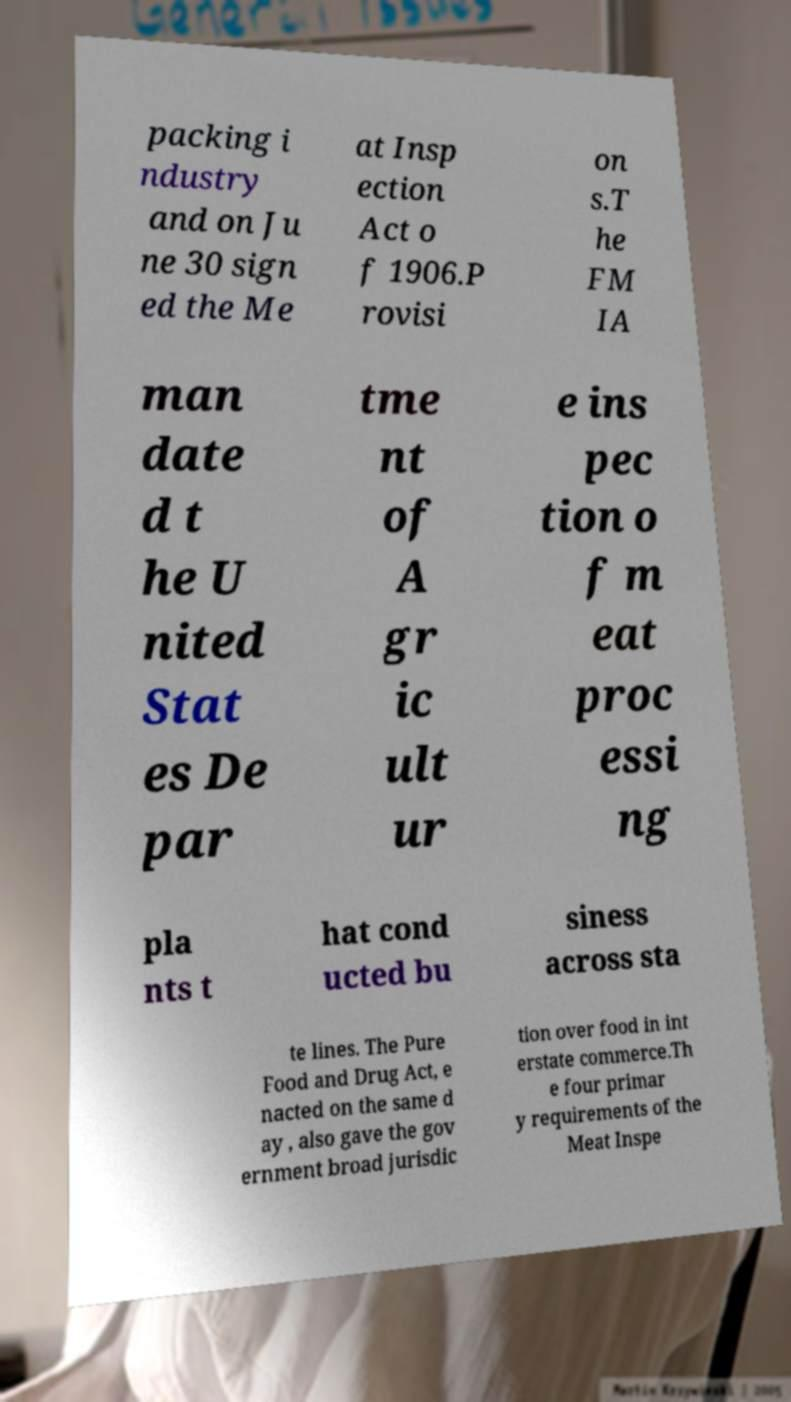Please read and relay the text visible in this image. What does it say? packing i ndustry and on Ju ne 30 sign ed the Me at Insp ection Act o f 1906.P rovisi on s.T he FM IA man date d t he U nited Stat es De par tme nt of A gr ic ult ur e ins pec tion o f m eat proc essi ng pla nts t hat cond ucted bu siness across sta te lines. The Pure Food and Drug Act, e nacted on the same d ay , also gave the gov ernment broad jurisdic tion over food in int erstate commerce.Th e four primar y requirements of the Meat Inspe 